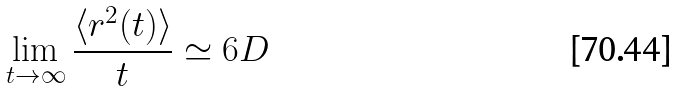Convert formula to latex. <formula><loc_0><loc_0><loc_500><loc_500>\lim _ { t \rightarrow \infty } \frac { \langle r ^ { 2 } ( t ) \rangle } { t } \simeq 6 D</formula> 